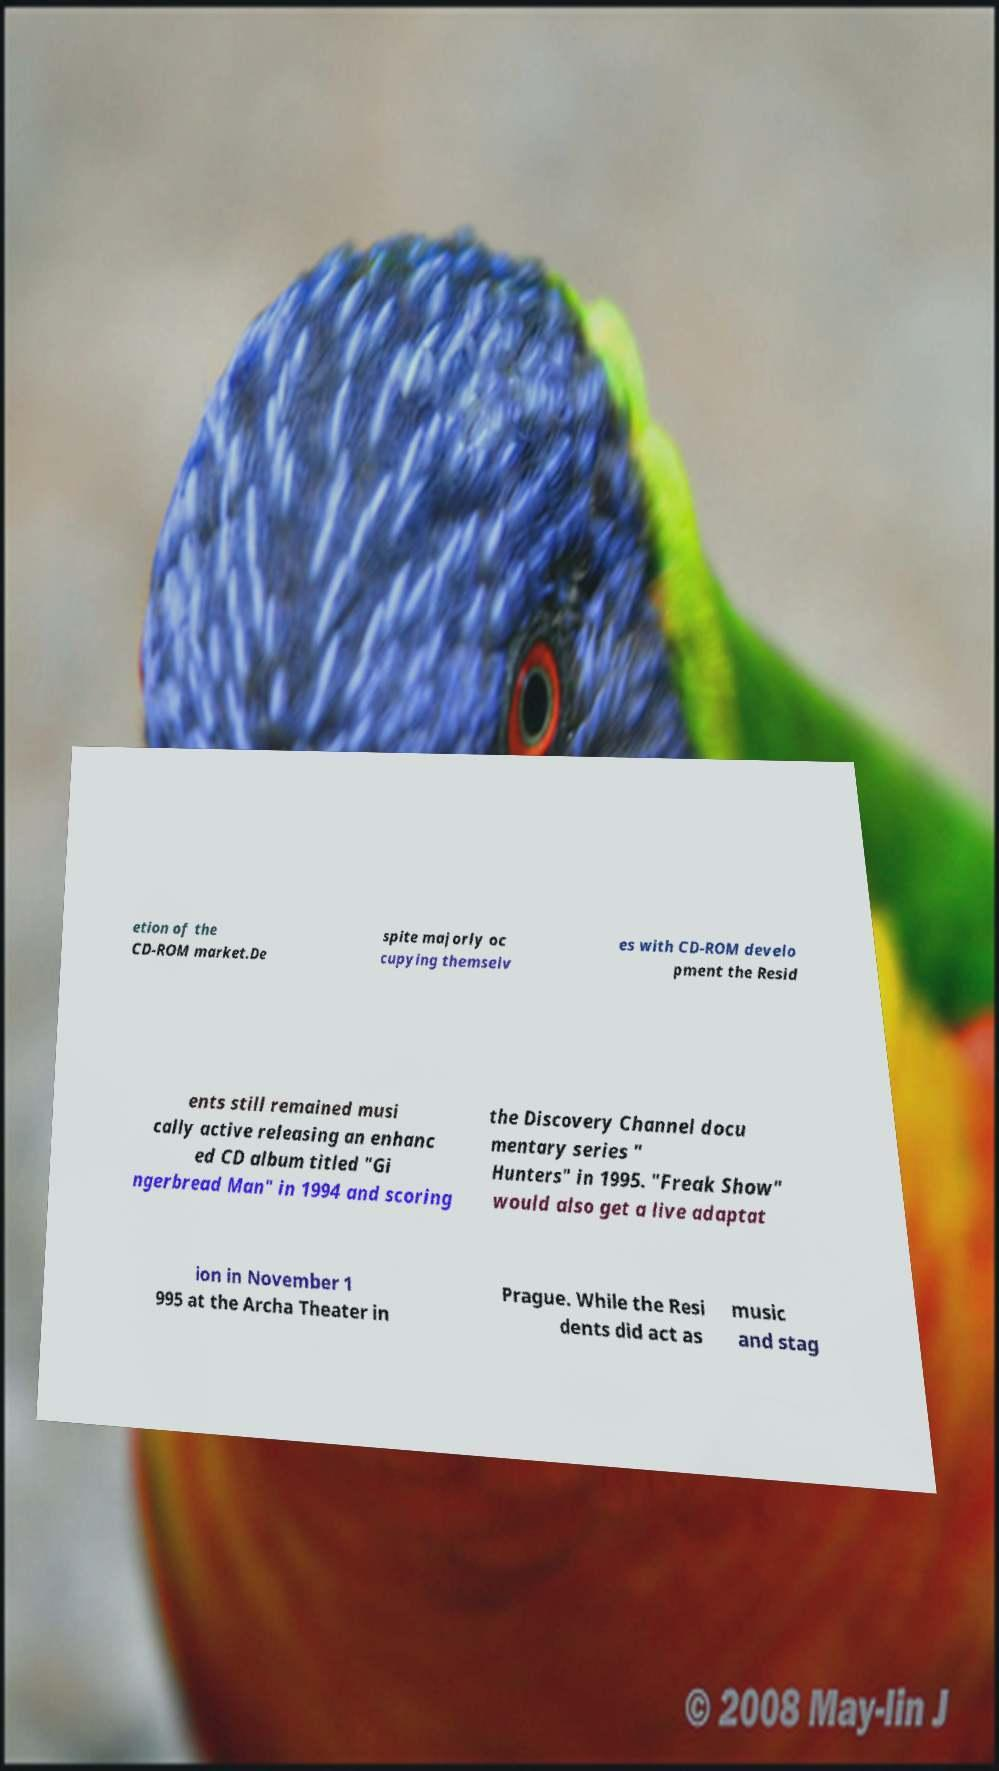For documentation purposes, I need the text within this image transcribed. Could you provide that? etion of the CD-ROM market.De spite majorly oc cupying themselv es with CD-ROM develo pment the Resid ents still remained musi cally active releasing an enhanc ed CD album titled "Gi ngerbread Man" in 1994 and scoring the Discovery Channel docu mentary series " Hunters" in 1995. "Freak Show" would also get a live adaptat ion in November 1 995 at the Archa Theater in Prague. While the Resi dents did act as music and stag 